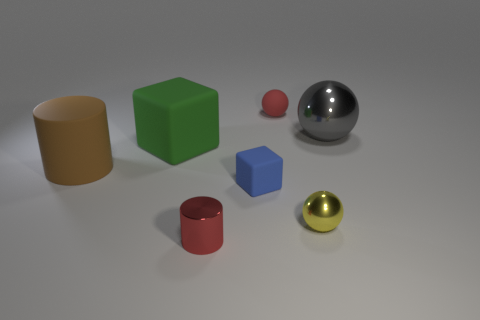Add 1 big red cylinders. How many objects exist? 8 Subtract all cubes. How many objects are left? 5 Subtract all big gray objects. Subtract all large gray spheres. How many objects are left? 5 Add 7 small blue rubber objects. How many small blue rubber objects are left? 8 Add 1 brown matte spheres. How many brown matte spheres exist? 1 Subtract 1 brown cylinders. How many objects are left? 6 